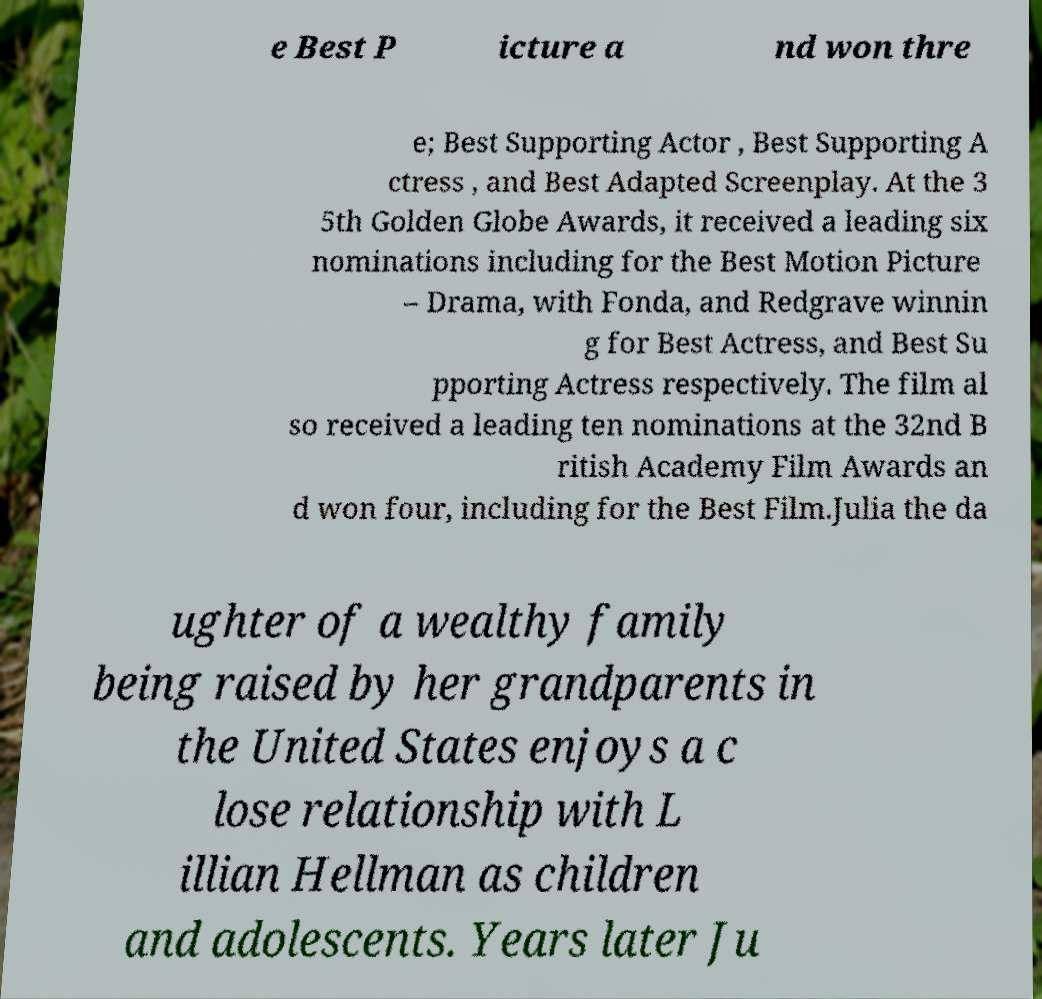For documentation purposes, I need the text within this image transcribed. Could you provide that? e Best P icture a nd won thre e; Best Supporting Actor , Best Supporting A ctress , and Best Adapted Screenplay. At the 3 5th Golden Globe Awards, it received a leading six nominations including for the Best Motion Picture – Drama, with Fonda, and Redgrave winnin g for Best Actress, and Best Su pporting Actress respectively. The film al so received a leading ten nominations at the 32nd B ritish Academy Film Awards an d won four, including for the Best Film.Julia the da ughter of a wealthy family being raised by her grandparents in the United States enjoys a c lose relationship with L illian Hellman as children and adolescents. Years later Ju 